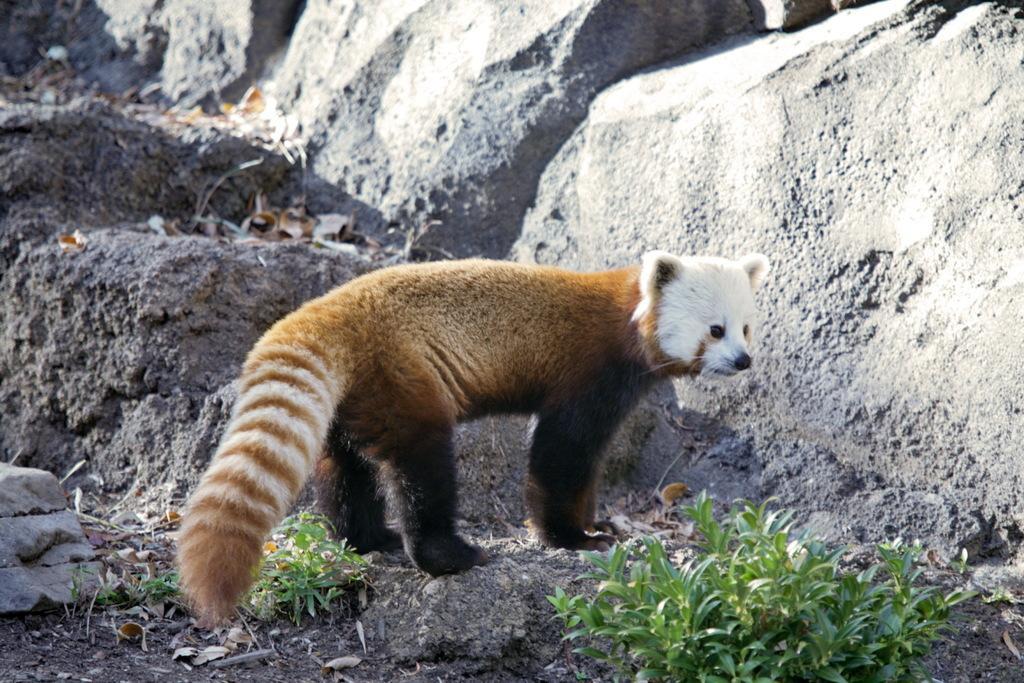How would you summarize this image in a sentence or two? In this image, I can see red panda. At the bottom of the image, there are plants. In the background, I can see the rocks. 